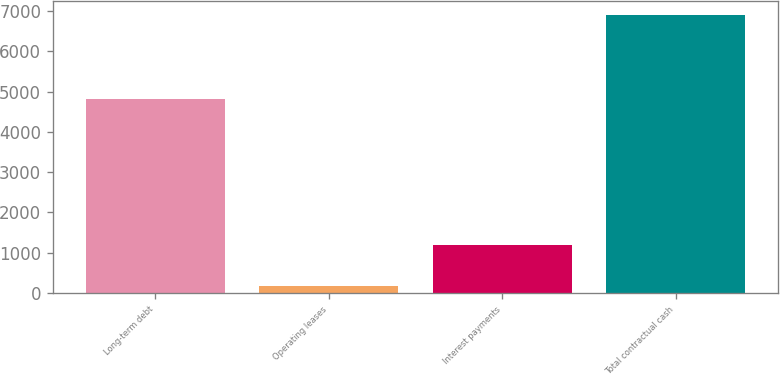<chart> <loc_0><loc_0><loc_500><loc_500><bar_chart><fcel>Long-term debt<fcel>Operating leases<fcel>Interest payments<fcel>Total contractual cash<nl><fcel>4805.9<fcel>172<fcel>1187.5<fcel>6910.2<nl></chart> 